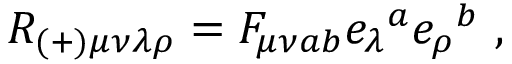Convert formula to latex. <formula><loc_0><loc_0><loc_500><loc_500>R _ { ( + ) \mu \nu \lambda \rho } = F _ { \mu \nu a b } e _ { \lambda ^ { a } e _ { \rho ^ { b } \ ,</formula> 